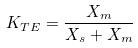<formula> <loc_0><loc_0><loc_500><loc_500>K _ { T E } = \frac { X _ { m } } { X _ { s } + X _ { m } }</formula> 